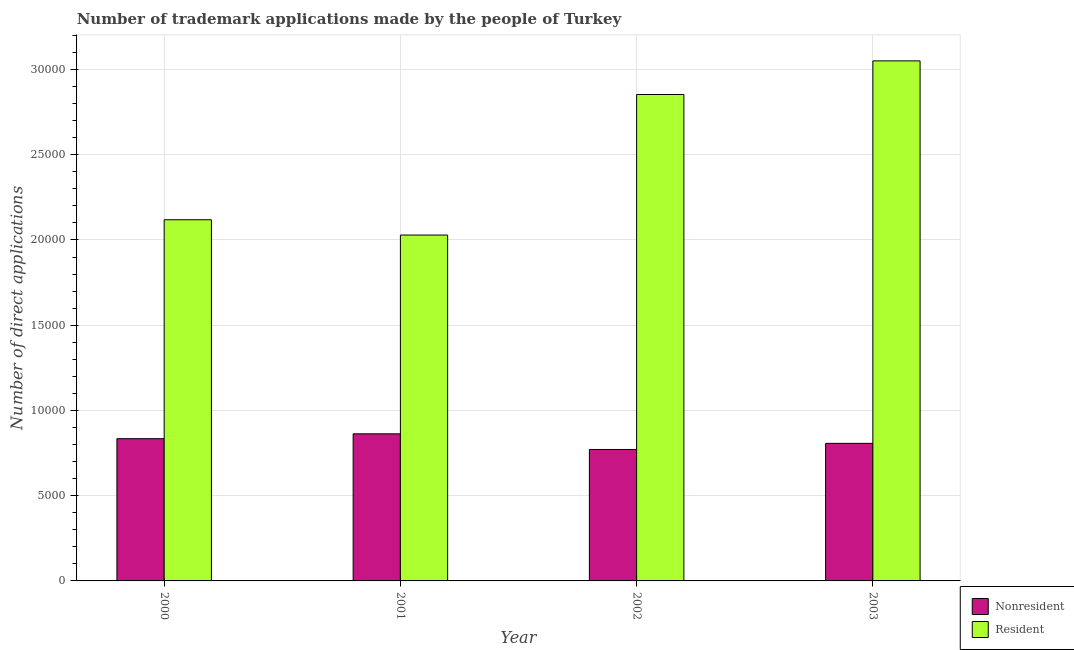How many different coloured bars are there?
Ensure brevity in your answer.  2. Are the number of bars on each tick of the X-axis equal?
Provide a succinct answer. Yes. How many bars are there on the 4th tick from the right?
Your answer should be compact. 2. What is the label of the 3rd group of bars from the left?
Your answer should be very brief. 2002. What is the number of trademark applications made by non residents in 2002?
Provide a short and direct response. 7711. Across all years, what is the maximum number of trademark applications made by residents?
Provide a short and direct response. 3.05e+04. Across all years, what is the minimum number of trademark applications made by residents?
Give a very brief answer. 2.03e+04. What is the total number of trademark applications made by non residents in the graph?
Offer a terse response. 3.28e+04. What is the difference between the number of trademark applications made by non residents in 2000 and that in 2003?
Your answer should be very brief. 274. What is the difference between the number of trademark applications made by residents in 2003 and the number of trademark applications made by non residents in 2002?
Your answer should be compact. 1973. What is the average number of trademark applications made by residents per year?
Ensure brevity in your answer.  2.51e+04. What is the ratio of the number of trademark applications made by residents in 2001 to that in 2002?
Provide a short and direct response. 0.71. What is the difference between the highest and the second highest number of trademark applications made by residents?
Offer a very short reply. 1973. What is the difference between the highest and the lowest number of trademark applications made by non residents?
Make the answer very short. 917. In how many years, is the number of trademark applications made by residents greater than the average number of trademark applications made by residents taken over all years?
Provide a succinct answer. 2. What does the 2nd bar from the left in 2001 represents?
Offer a very short reply. Resident. What does the 2nd bar from the right in 2002 represents?
Ensure brevity in your answer.  Nonresident. How many bars are there?
Provide a succinct answer. 8. Are the values on the major ticks of Y-axis written in scientific E-notation?
Your answer should be very brief. No. Does the graph contain grids?
Offer a terse response. Yes. How many legend labels are there?
Provide a short and direct response. 2. How are the legend labels stacked?
Ensure brevity in your answer.  Vertical. What is the title of the graph?
Give a very brief answer. Number of trademark applications made by the people of Turkey. What is the label or title of the Y-axis?
Offer a terse response. Number of direct applications. What is the Number of direct applications of Nonresident in 2000?
Provide a short and direct response. 8344. What is the Number of direct applications in Resident in 2000?
Your answer should be very brief. 2.12e+04. What is the Number of direct applications in Nonresident in 2001?
Provide a succinct answer. 8628. What is the Number of direct applications in Resident in 2001?
Provide a short and direct response. 2.03e+04. What is the Number of direct applications in Nonresident in 2002?
Your response must be concise. 7711. What is the Number of direct applications of Resident in 2002?
Offer a terse response. 2.85e+04. What is the Number of direct applications of Nonresident in 2003?
Offer a terse response. 8070. What is the Number of direct applications of Resident in 2003?
Make the answer very short. 3.05e+04. Across all years, what is the maximum Number of direct applications in Nonresident?
Offer a terse response. 8628. Across all years, what is the maximum Number of direct applications in Resident?
Your answer should be compact. 3.05e+04. Across all years, what is the minimum Number of direct applications of Nonresident?
Keep it short and to the point. 7711. Across all years, what is the minimum Number of direct applications in Resident?
Your answer should be compact. 2.03e+04. What is the total Number of direct applications in Nonresident in the graph?
Provide a short and direct response. 3.28e+04. What is the total Number of direct applications in Resident in the graph?
Ensure brevity in your answer.  1.01e+05. What is the difference between the Number of direct applications in Nonresident in 2000 and that in 2001?
Provide a succinct answer. -284. What is the difference between the Number of direct applications in Resident in 2000 and that in 2001?
Offer a terse response. 899. What is the difference between the Number of direct applications in Nonresident in 2000 and that in 2002?
Offer a very short reply. 633. What is the difference between the Number of direct applications of Resident in 2000 and that in 2002?
Your answer should be very brief. -7346. What is the difference between the Number of direct applications in Nonresident in 2000 and that in 2003?
Give a very brief answer. 274. What is the difference between the Number of direct applications in Resident in 2000 and that in 2003?
Ensure brevity in your answer.  -9319. What is the difference between the Number of direct applications of Nonresident in 2001 and that in 2002?
Offer a terse response. 917. What is the difference between the Number of direct applications in Resident in 2001 and that in 2002?
Ensure brevity in your answer.  -8245. What is the difference between the Number of direct applications of Nonresident in 2001 and that in 2003?
Your answer should be very brief. 558. What is the difference between the Number of direct applications of Resident in 2001 and that in 2003?
Offer a terse response. -1.02e+04. What is the difference between the Number of direct applications of Nonresident in 2002 and that in 2003?
Your answer should be very brief. -359. What is the difference between the Number of direct applications in Resident in 2002 and that in 2003?
Offer a terse response. -1973. What is the difference between the Number of direct applications in Nonresident in 2000 and the Number of direct applications in Resident in 2001?
Your answer should be very brief. -1.19e+04. What is the difference between the Number of direct applications of Nonresident in 2000 and the Number of direct applications of Resident in 2002?
Provide a short and direct response. -2.02e+04. What is the difference between the Number of direct applications in Nonresident in 2000 and the Number of direct applications in Resident in 2003?
Provide a short and direct response. -2.22e+04. What is the difference between the Number of direct applications of Nonresident in 2001 and the Number of direct applications of Resident in 2002?
Make the answer very short. -1.99e+04. What is the difference between the Number of direct applications of Nonresident in 2001 and the Number of direct applications of Resident in 2003?
Provide a succinct answer. -2.19e+04. What is the difference between the Number of direct applications of Nonresident in 2002 and the Number of direct applications of Resident in 2003?
Your response must be concise. -2.28e+04. What is the average Number of direct applications in Nonresident per year?
Ensure brevity in your answer.  8188.25. What is the average Number of direct applications in Resident per year?
Provide a succinct answer. 2.51e+04. In the year 2000, what is the difference between the Number of direct applications of Nonresident and Number of direct applications of Resident?
Offer a very short reply. -1.28e+04. In the year 2001, what is the difference between the Number of direct applications in Nonresident and Number of direct applications in Resident?
Provide a succinct answer. -1.17e+04. In the year 2002, what is the difference between the Number of direct applications of Nonresident and Number of direct applications of Resident?
Ensure brevity in your answer.  -2.08e+04. In the year 2003, what is the difference between the Number of direct applications of Nonresident and Number of direct applications of Resident?
Make the answer very short. -2.24e+04. What is the ratio of the Number of direct applications of Nonresident in 2000 to that in 2001?
Give a very brief answer. 0.97. What is the ratio of the Number of direct applications in Resident in 2000 to that in 2001?
Give a very brief answer. 1.04. What is the ratio of the Number of direct applications of Nonresident in 2000 to that in 2002?
Provide a short and direct response. 1.08. What is the ratio of the Number of direct applications in Resident in 2000 to that in 2002?
Make the answer very short. 0.74. What is the ratio of the Number of direct applications of Nonresident in 2000 to that in 2003?
Keep it short and to the point. 1.03. What is the ratio of the Number of direct applications in Resident in 2000 to that in 2003?
Keep it short and to the point. 0.69. What is the ratio of the Number of direct applications in Nonresident in 2001 to that in 2002?
Provide a succinct answer. 1.12. What is the ratio of the Number of direct applications in Resident in 2001 to that in 2002?
Offer a very short reply. 0.71. What is the ratio of the Number of direct applications of Nonresident in 2001 to that in 2003?
Give a very brief answer. 1.07. What is the ratio of the Number of direct applications in Resident in 2001 to that in 2003?
Your response must be concise. 0.67. What is the ratio of the Number of direct applications in Nonresident in 2002 to that in 2003?
Provide a succinct answer. 0.96. What is the ratio of the Number of direct applications in Resident in 2002 to that in 2003?
Keep it short and to the point. 0.94. What is the difference between the highest and the second highest Number of direct applications of Nonresident?
Offer a terse response. 284. What is the difference between the highest and the second highest Number of direct applications of Resident?
Keep it short and to the point. 1973. What is the difference between the highest and the lowest Number of direct applications of Nonresident?
Offer a very short reply. 917. What is the difference between the highest and the lowest Number of direct applications in Resident?
Offer a terse response. 1.02e+04. 